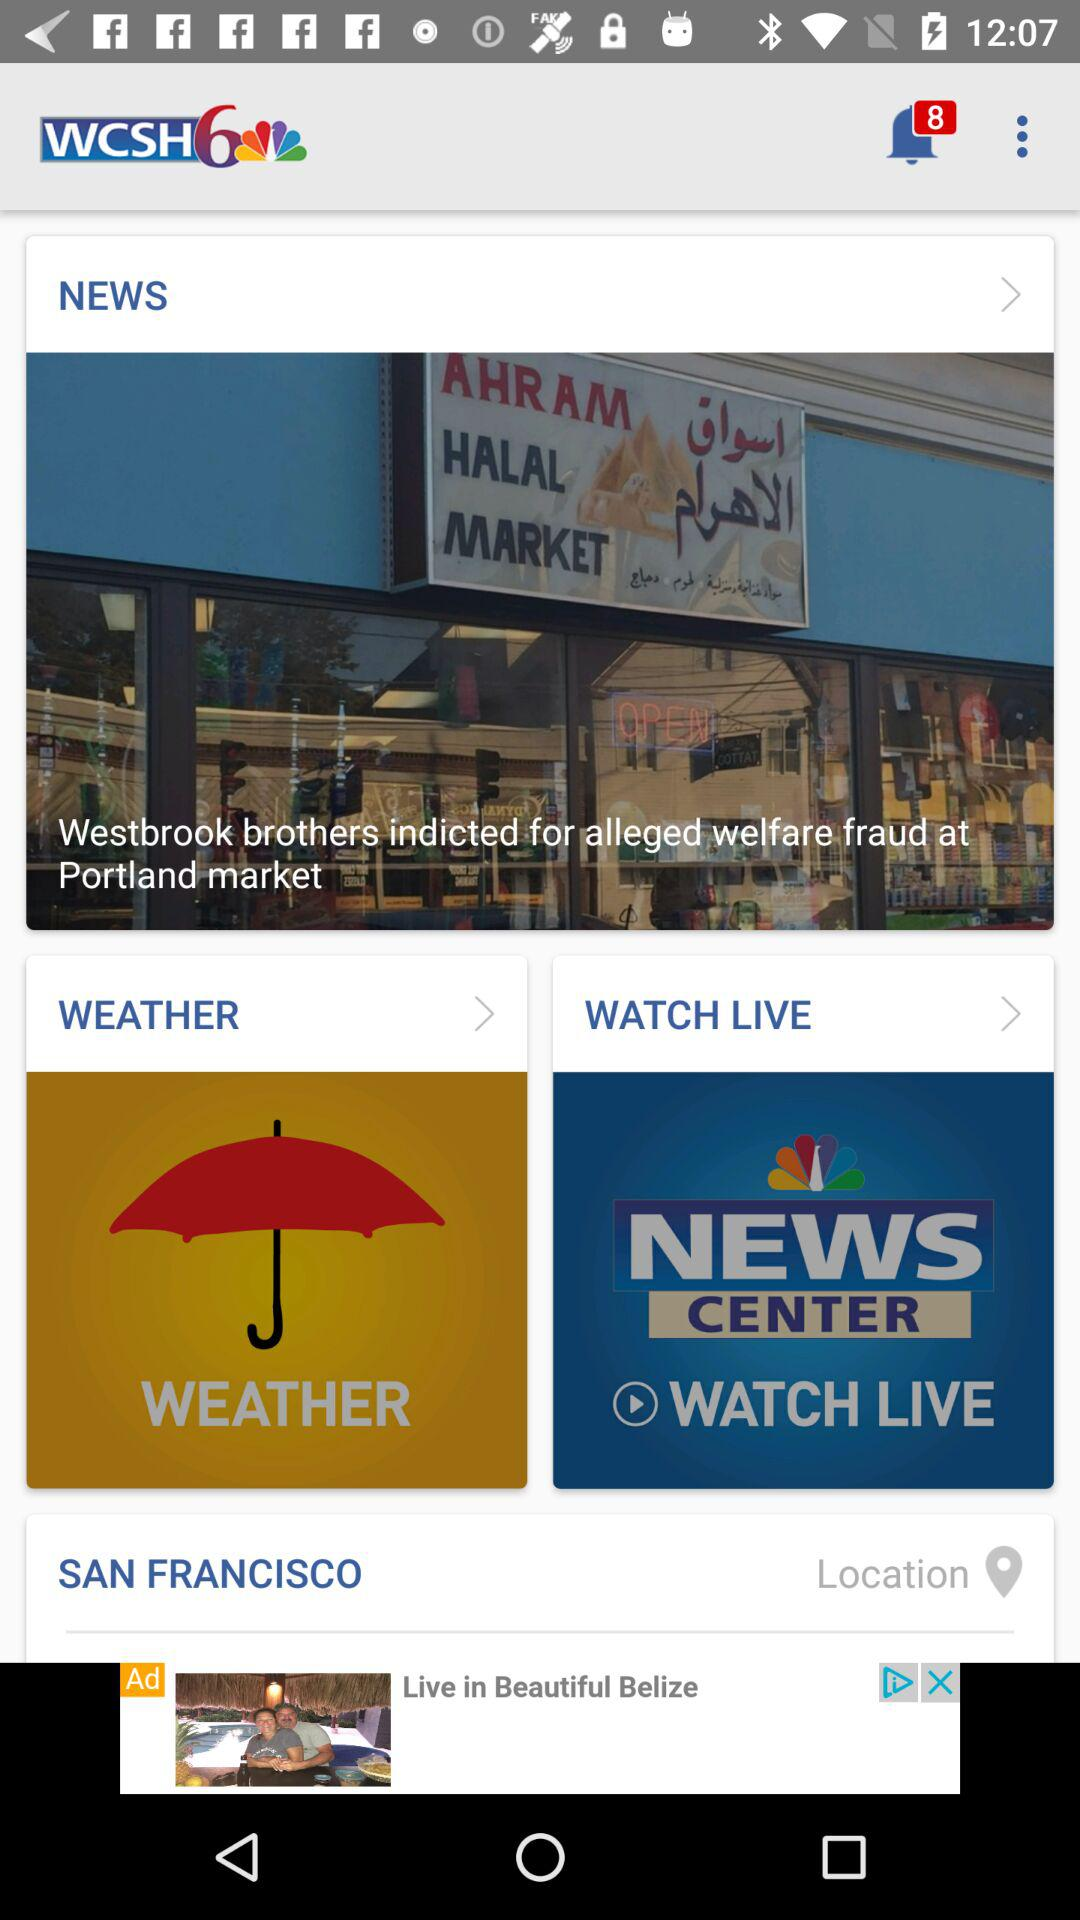What is the location? The location is San Francisco. 